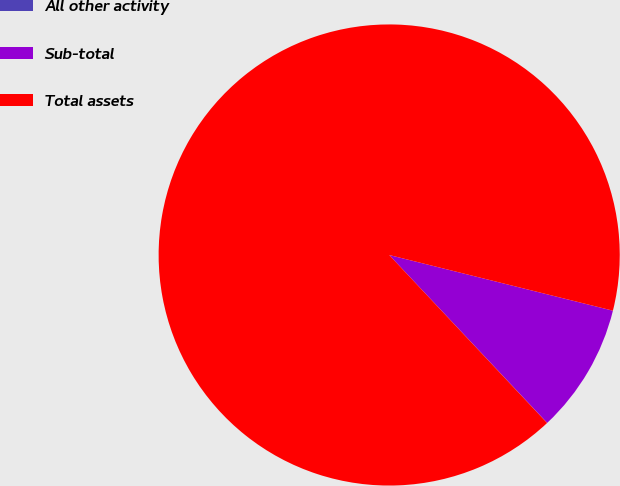<chart> <loc_0><loc_0><loc_500><loc_500><pie_chart><fcel>All other activity<fcel>Sub-total<fcel>Total assets<nl><fcel>0.01%<fcel>9.1%<fcel>90.89%<nl></chart> 